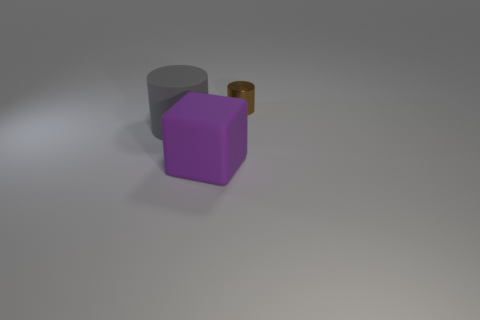Is there any other thing that is the same size as the brown object?
Provide a short and direct response. No. Is there anything else that is the same shape as the large purple thing?
Provide a succinct answer. No. How many other objects are there of the same color as the rubber cylinder?
Ensure brevity in your answer.  0. Are there fewer purple metal cylinders than big matte cylinders?
Offer a very short reply. Yes. The thing that is both behind the rubber cube and to the left of the brown cylinder is what color?
Provide a short and direct response. Gray. There is a large object that is the same shape as the tiny brown object; what is it made of?
Your answer should be very brief. Rubber. Is the number of large objects greater than the number of big yellow matte balls?
Provide a short and direct response. Yes. There is a object that is to the right of the big gray cylinder and behind the purple rubber block; what is its size?
Make the answer very short. Small. There is a big gray matte object; what shape is it?
Make the answer very short. Cylinder. What number of other brown shiny objects have the same shape as the brown metal object?
Your answer should be very brief. 0. 